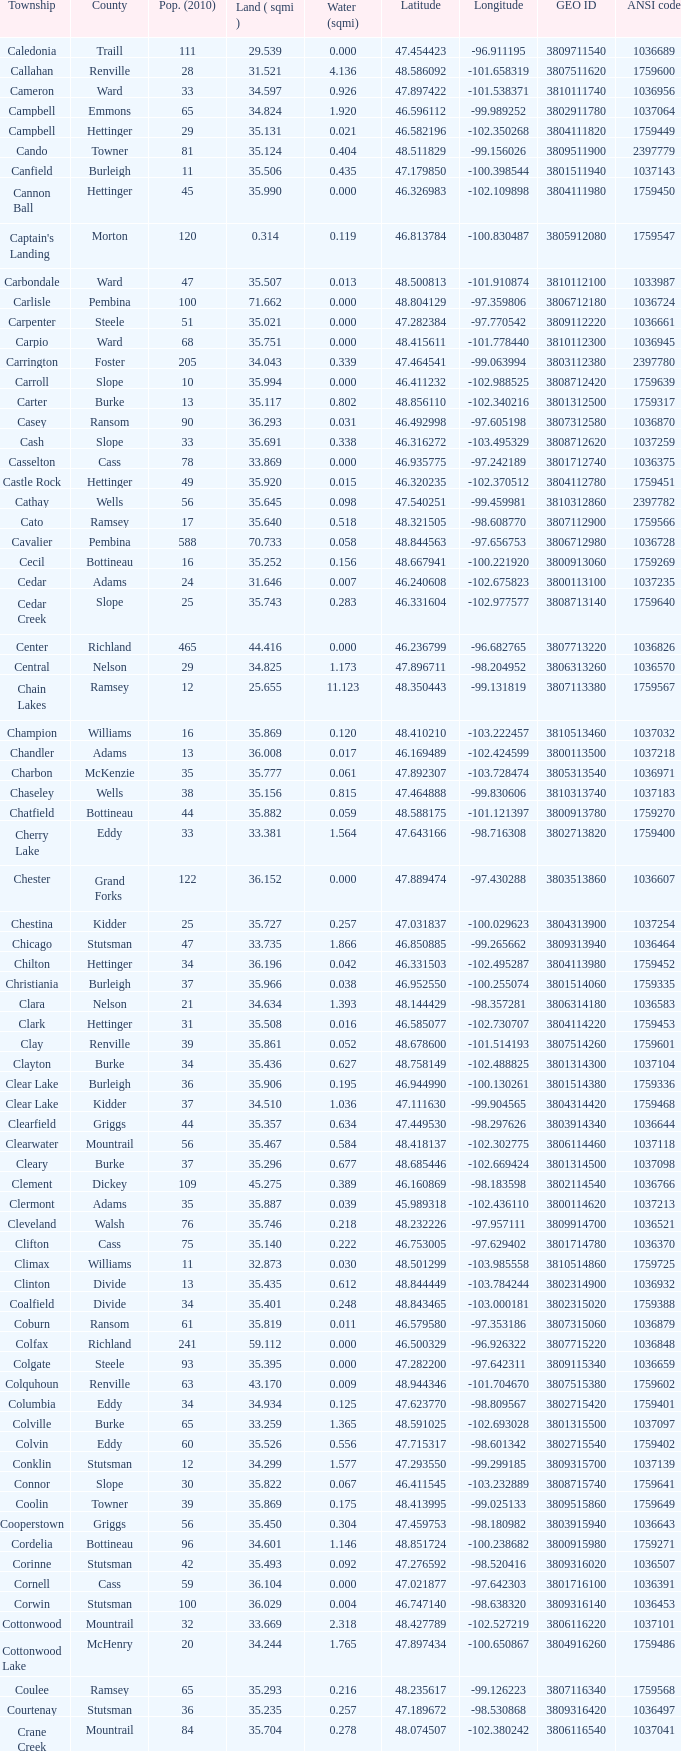Which township had a geo id of 3807116660? Creel. 